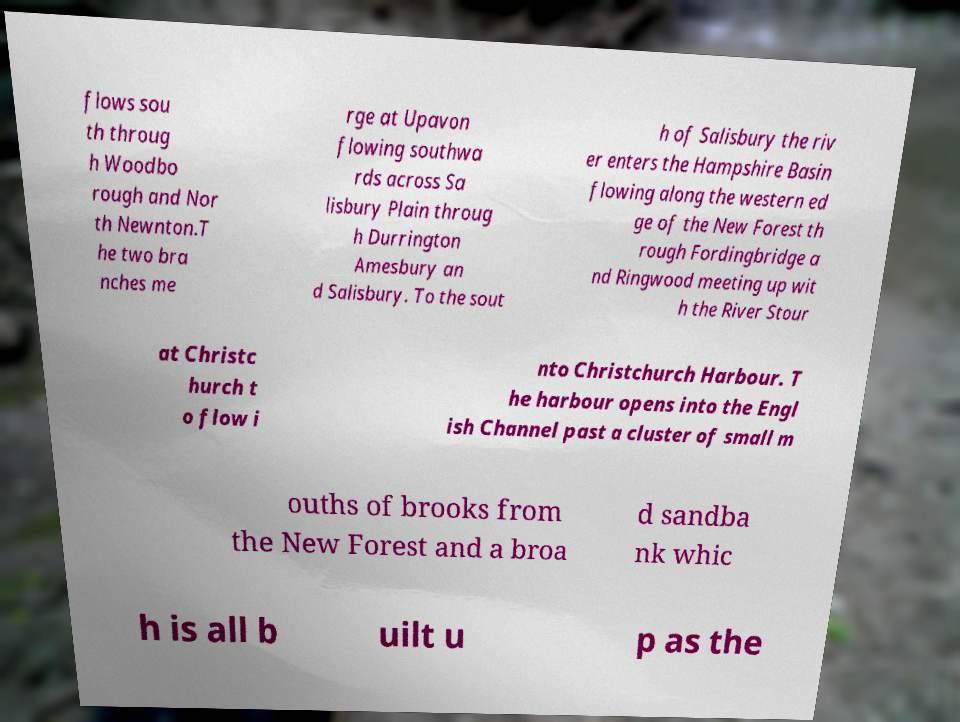What messages or text are displayed in this image? I need them in a readable, typed format. flows sou th throug h Woodbo rough and Nor th Newnton.T he two bra nches me rge at Upavon flowing southwa rds across Sa lisbury Plain throug h Durrington Amesbury an d Salisbury. To the sout h of Salisbury the riv er enters the Hampshire Basin flowing along the western ed ge of the New Forest th rough Fordingbridge a nd Ringwood meeting up wit h the River Stour at Christc hurch t o flow i nto Christchurch Harbour. T he harbour opens into the Engl ish Channel past a cluster of small m ouths of brooks from the New Forest and a broa d sandba nk whic h is all b uilt u p as the 